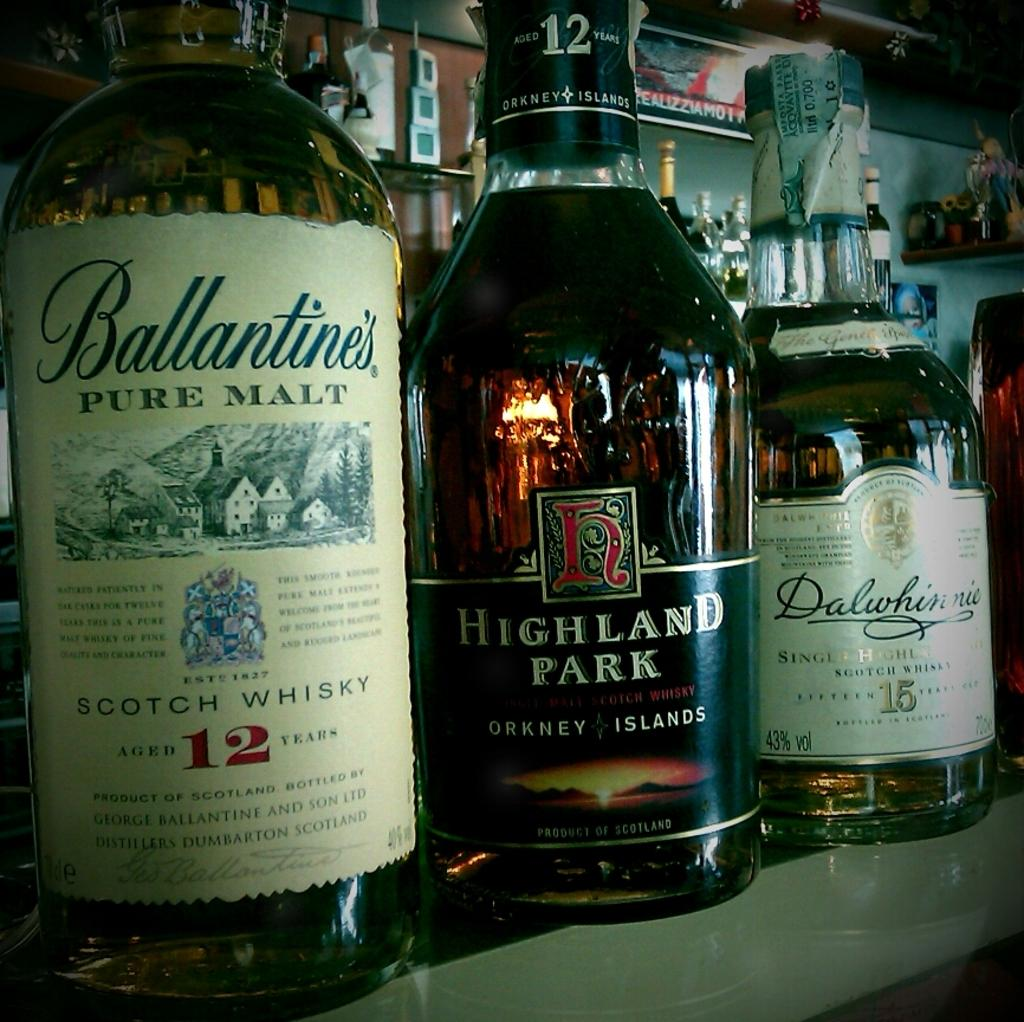<image>
Summarize the visual content of the image. Bottles of liquor are lined up including one by Highland Park. 